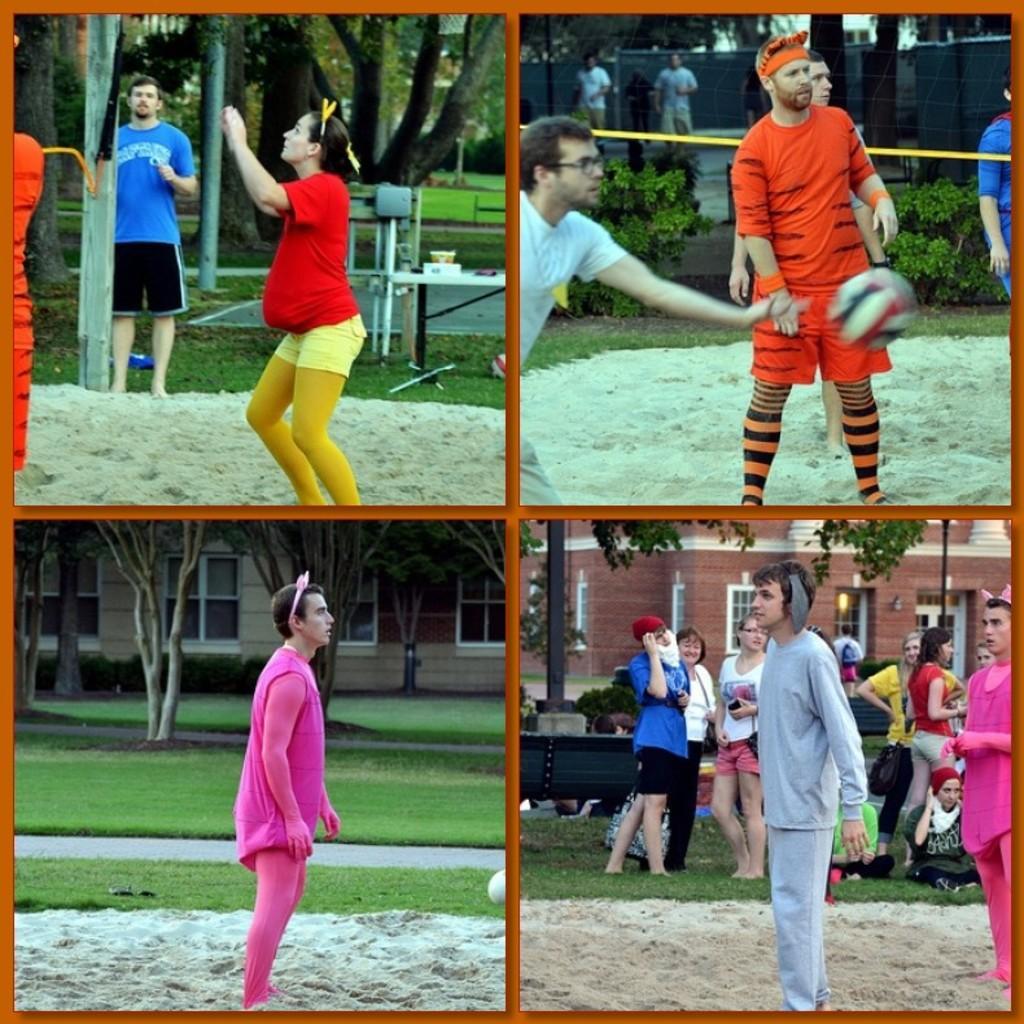In one or two sentences, can you explain what this image depicts? In this image I can see the collage picture in which I can see few persons are standing on the ground, some grass on the ground, some sand, few trees, few buildings, few windows of the buildings and I can see a ball over here. 